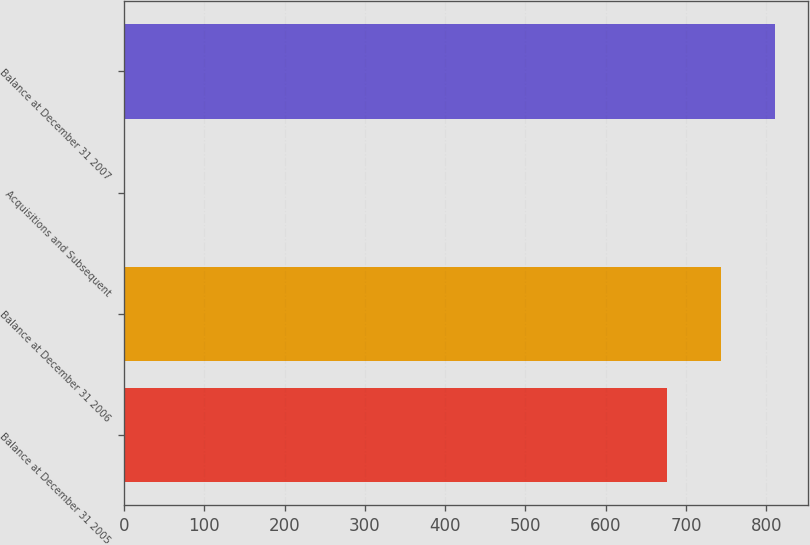<chart> <loc_0><loc_0><loc_500><loc_500><bar_chart><fcel>Balance at December 31 2005<fcel>Balance at December 31 2006<fcel>Acquisitions and Subsequent<fcel>Balance at December 31 2007<nl><fcel>676<fcel>743.6<fcel>1<fcel>811.2<nl></chart> 